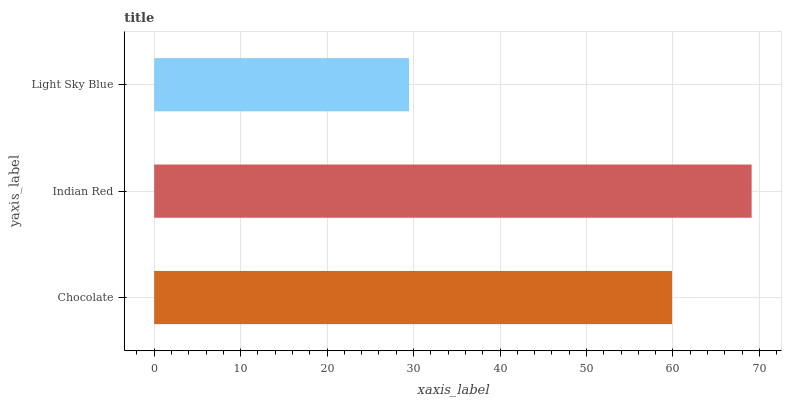Is Light Sky Blue the minimum?
Answer yes or no. Yes. Is Indian Red the maximum?
Answer yes or no. Yes. Is Indian Red the minimum?
Answer yes or no. No. Is Light Sky Blue the maximum?
Answer yes or no. No. Is Indian Red greater than Light Sky Blue?
Answer yes or no. Yes. Is Light Sky Blue less than Indian Red?
Answer yes or no. Yes. Is Light Sky Blue greater than Indian Red?
Answer yes or no. No. Is Indian Red less than Light Sky Blue?
Answer yes or no. No. Is Chocolate the high median?
Answer yes or no. Yes. Is Chocolate the low median?
Answer yes or no. Yes. Is Light Sky Blue the high median?
Answer yes or no. No. Is Indian Red the low median?
Answer yes or no. No. 